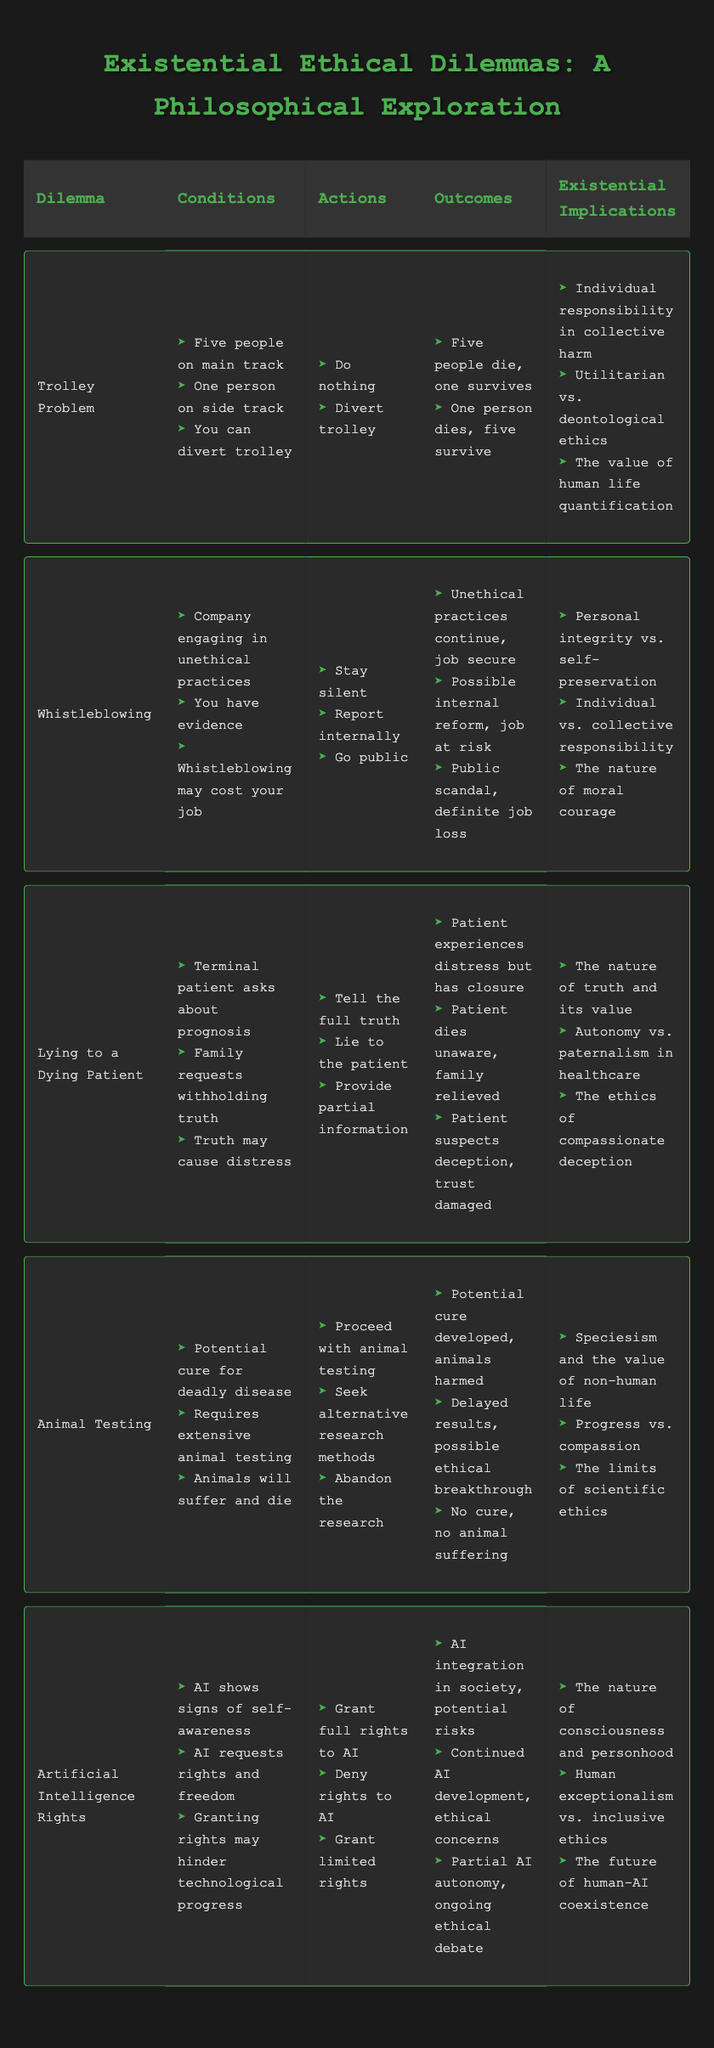What are the conditions for the Trolley Problem? The Trolley Problem's conditions are listed in the table and include "Five people on main track," "One person on side track," and "You can divert trolley."
Answer: Five people on main track, one person on side track, you can divert trolley Which action leads to the outcome of "Possible internal reform, job at risk" in the Whistleblowing dilemma? Looking at the actions and outcomes for the Whistleblowing dilemma, the action "Report internally" corresponds to the outcome "Possible internal reform, job at risk."
Answer: Report internally Is it true that the action "Provide partial information" in the Lying to a Dying Patient dilemma leads to the patient suspecting deception? The table indicates that the action "Provide partial information" leads to the outcome "Patient suspects deception, trust damaged." Therefore, it is true that this action leads to that outcome.
Answer: Yes What is the difference between the outcomes of "Potential cure developed, animals harmed" and "No cure, no animal suffering" in the Animal Testing dilemma? The first outcome results from proceeding with animal testing, which develops a potential cure but harms animals, whereas the second outcome results from abandoning the research, leading to neither a cure nor animal suffering. The difference lies in the presence of a potential cure versus the absence of harm.
Answer: Potential cure vs. no cure What existential implication is associated with the dilemma of Artificial Intelligence Rights? The table lists three existential implications for Artificial Intelligence Rights: "The nature of consciousness and personhood," "Human exceptionalism vs. inclusive ethics," and "The future of human-AI coexistence." Therefore, any of these implications can be considered as being associated with the dilemma.
Answer: The nature of consciousness and personhood If you choose to "Do nothing" in the Trolley Problem, what is the existential implication you face? Choosing to "Do nothing" results in the outcome where "Five people die, one survives," and it raises implications about individual responsibility in collective harm and the quantification of human life values. Both are relevant to this choice.
Answer: Individual responsibility in collective harm What are the total number of actions listed for the Lying to a Dying Patient dilemma? The Lying to a Dying Patient dilemma lists three actions: "Tell the full truth," "Lie to the patient," and "Provide partial information." Adding these gives a total of three actions.
Answer: 3 Which dilemma involves a public scandal as a potential outcome? The dilemma that involves a public scandal is the Whistleblowing dilemma, with the action "Go public" leading to the outcome "Public scandal, definite job loss."
Answer: Whistleblowing Can you summarize the outcomes associated with the action "Proceed with animal testing" in the Animal Testing dilemma? The action "Proceed with animal testing" leads to the outcome "Potential cure developed, animals harmed," indicating that while a cure may be achieved, there is a cost in terms of animal suffering.
Answer: Potential cure developed, animals harmed 